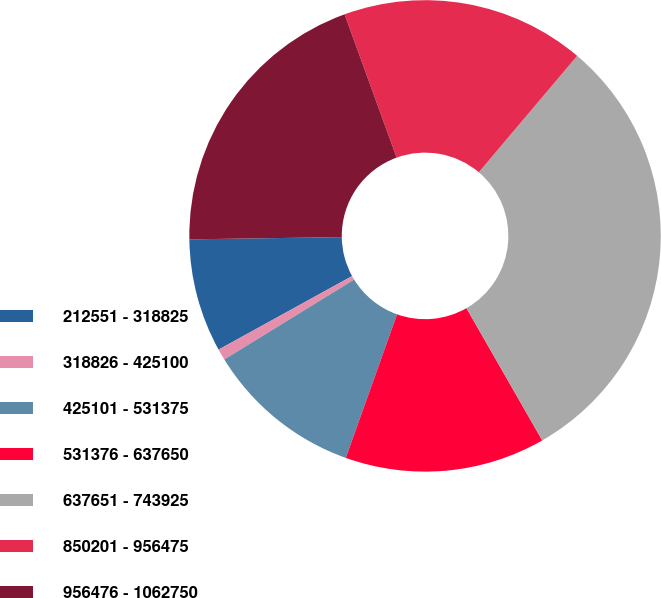Convert chart to OTSL. <chart><loc_0><loc_0><loc_500><loc_500><pie_chart><fcel>212551 - 318825<fcel>318826 - 425100<fcel>425101 - 531375<fcel>531376 - 637650<fcel>637651 - 743925<fcel>850201 - 956475<fcel>956476 - 1062750<nl><fcel>7.78%<fcel>0.77%<fcel>10.76%<fcel>13.74%<fcel>30.55%<fcel>16.71%<fcel>19.69%<nl></chart> 